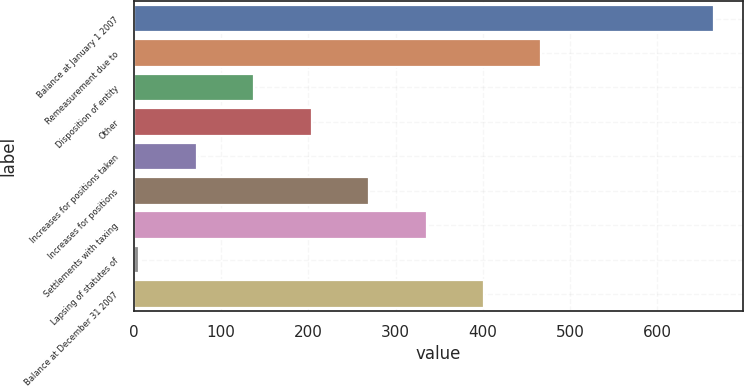Convert chart to OTSL. <chart><loc_0><loc_0><loc_500><loc_500><bar_chart><fcel>Balance at January 1 2007<fcel>Remeasurement due to<fcel>Disposition of entity<fcel>Other<fcel>Increases for positions taken<fcel>Increases for positions<fcel>Settlements with taxing<fcel>Lapsing of statutes of<fcel>Balance at December 31 2007<nl><fcel>664.3<fcel>466.99<fcel>138.14<fcel>203.91<fcel>72.37<fcel>269.68<fcel>335.45<fcel>6.6<fcel>401.22<nl></chart> 